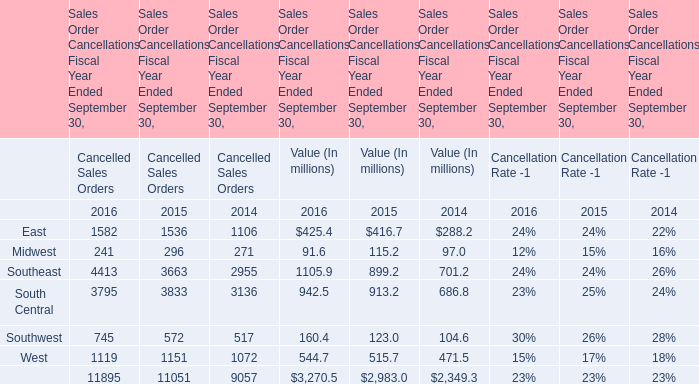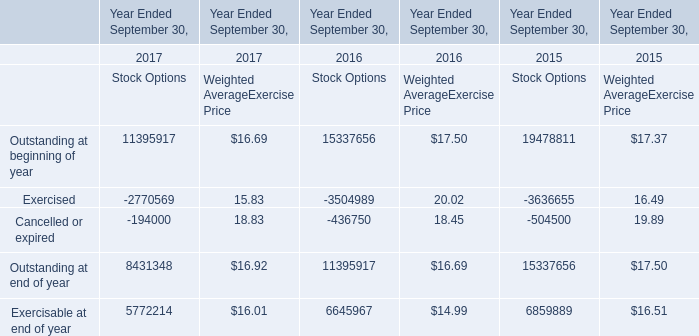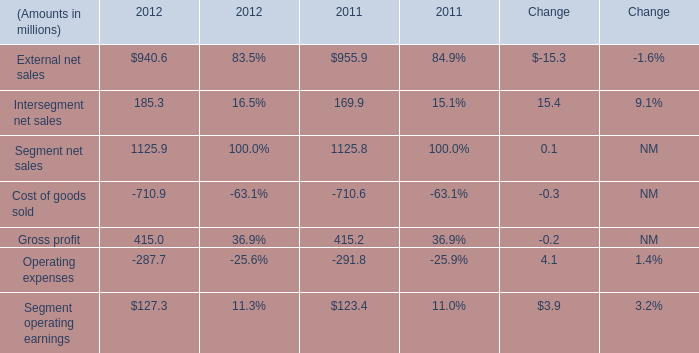What will the total Value of Sales Order Cancellations Fiscal Year Ended September 30 reach in 2017 if it continues to grow at its current rate? (in million) 
Computations: (3270.5 * (1 + ((3270.5 - 2983.0) / 2983.0)))
Answer: 3585.7091. 